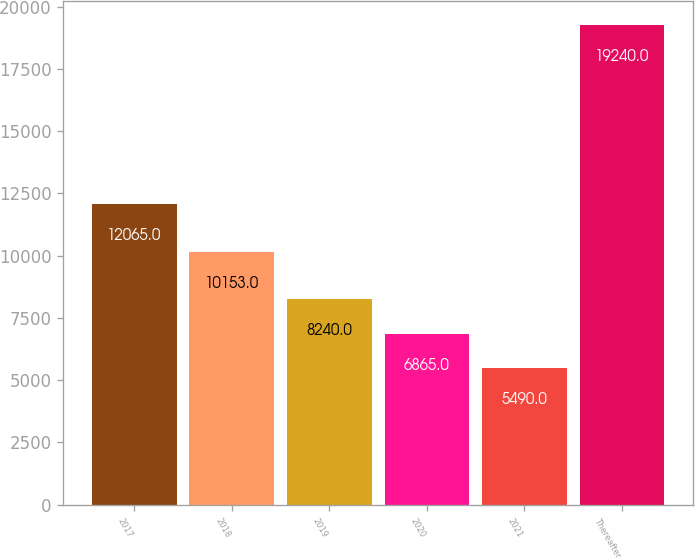Convert chart to OTSL. <chart><loc_0><loc_0><loc_500><loc_500><bar_chart><fcel>2017<fcel>2018<fcel>2019<fcel>2020<fcel>2021<fcel>Thereafter<nl><fcel>12065<fcel>10153<fcel>8240<fcel>6865<fcel>5490<fcel>19240<nl></chart> 